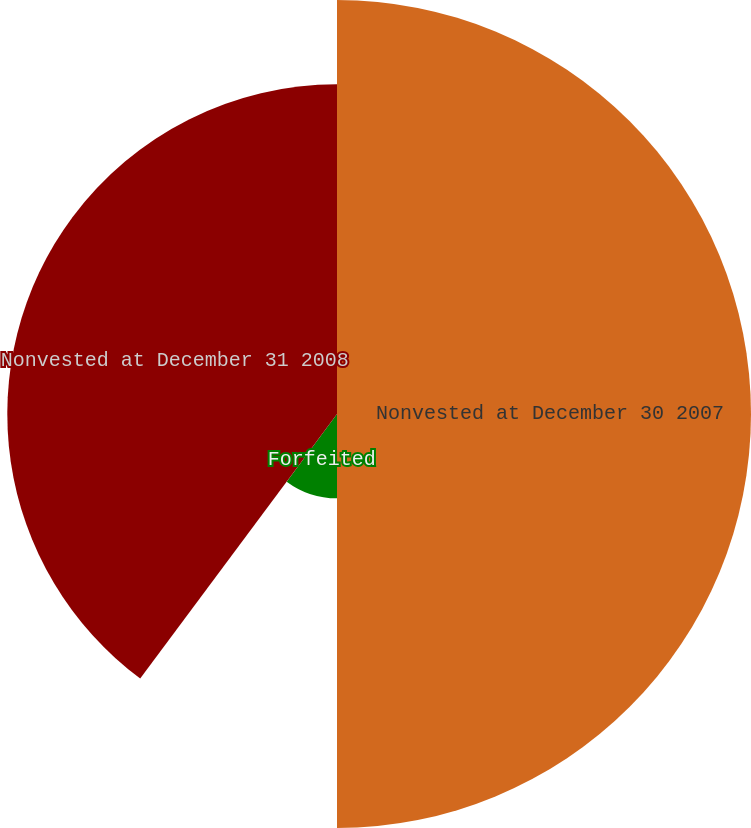Convert chart to OTSL. <chart><loc_0><loc_0><loc_500><loc_500><pie_chart><fcel>Nonvested at December 30 2007<fcel>Forfeited<fcel>Nonvested at December 31 2008<nl><fcel>50.0%<fcel>10.18%<fcel>39.82%<nl></chart> 